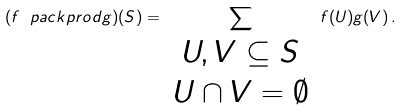Convert formula to latex. <formula><loc_0><loc_0><loc_500><loc_500>( f \ p a c k p r o d g ) ( S ) = \sum _ { \begin{array} { c } U , V \subseteq S \\ U \cap V = \emptyset \end{array} } f ( U ) g ( V ) \, .</formula> 